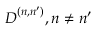<formula> <loc_0><loc_0><loc_500><loc_500>D ^ { ( n , n ^ { \prime } ) } , n \ne n ^ { \prime }</formula> 